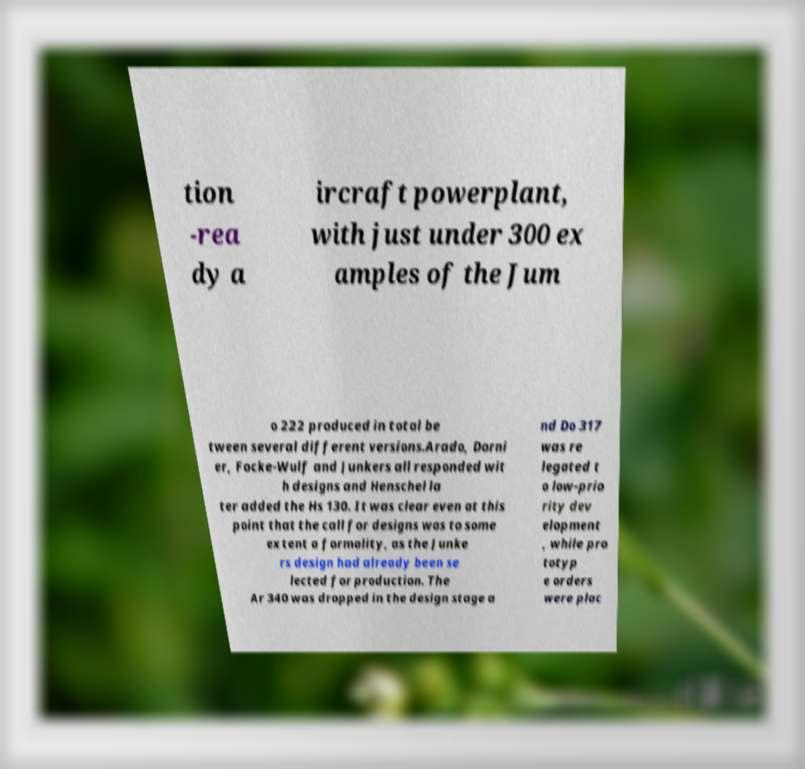For documentation purposes, I need the text within this image transcribed. Could you provide that? tion -rea dy a ircraft powerplant, with just under 300 ex amples of the Jum o 222 produced in total be tween several different versions.Arado, Dorni er, Focke-Wulf and Junkers all responded wit h designs and Henschel la ter added the Hs 130. It was clear even at this point that the call for designs was to some extent a formality, as the Junke rs design had already been se lected for production. The Ar 340 was dropped in the design stage a nd Do 317 was re legated t o low-prio rity dev elopment , while pro totyp e orders were plac 